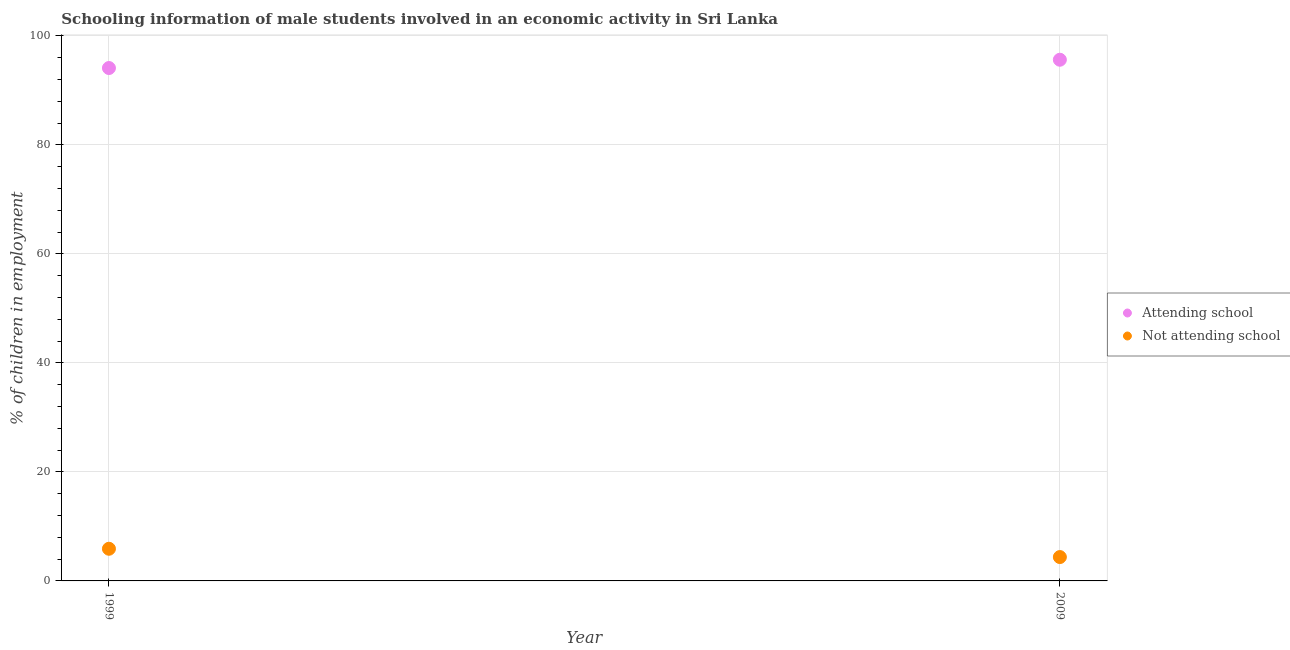Across all years, what is the maximum percentage of employed males who are attending school?
Offer a very short reply. 95.62. Across all years, what is the minimum percentage of employed males who are not attending school?
Keep it short and to the point. 4.38. In which year was the percentage of employed males who are attending school minimum?
Your answer should be very brief. 1999. What is the total percentage of employed males who are not attending school in the graph?
Provide a short and direct response. 10.28. What is the difference between the percentage of employed males who are attending school in 1999 and that in 2009?
Provide a succinct answer. -1.52. What is the difference between the percentage of employed males who are attending school in 1999 and the percentage of employed males who are not attending school in 2009?
Provide a short and direct response. 89.72. What is the average percentage of employed males who are not attending school per year?
Provide a succinct answer. 5.14. In the year 1999, what is the difference between the percentage of employed males who are attending school and percentage of employed males who are not attending school?
Ensure brevity in your answer.  88.2. In how many years, is the percentage of employed males who are not attending school greater than 8 %?
Give a very brief answer. 0. What is the ratio of the percentage of employed males who are not attending school in 1999 to that in 2009?
Your response must be concise. 1.35. In how many years, is the percentage of employed males who are attending school greater than the average percentage of employed males who are attending school taken over all years?
Your answer should be compact. 1. Is the percentage of employed males who are attending school strictly greater than the percentage of employed males who are not attending school over the years?
Offer a terse response. Yes. How many years are there in the graph?
Your answer should be very brief. 2. What is the difference between two consecutive major ticks on the Y-axis?
Offer a terse response. 20. Does the graph contain grids?
Your answer should be very brief. Yes. Where does the legend appear in the graph?
Offer a terse response. Center right. How many legend labels are there?
Offer a very short reply. 2. What is the title of the graph?
Give a very brief answer. Schooling information of male students involved in an economic activity in Sri Lanka. Does "Male entrants" appear as one of the legend labels in the graph?
Your response must be concise. No. What is the label or title of the Y-axis?
Provide a short and direct response. % of children in employment. What is the % of children in employment in Attending school in 1999?
Offer a very short reply. 94.1. What is the % of children in employment of Attending school in 2009?
Your answer should be compact. 95.62. What is the % of children in employment in Not attending school in 2009?
Ensure brevity in your answer.  4.38. Across all years, what is the maximum % of children in employment in Attending school?
Provide a short and direct response. 95.62. Across all years, what is the minimum % of children in employment of Attending school?
Keep it short and to the point. 94.1. Across all years, what is the minimum % of children in employment in Not attending school?
Provide a succinct answer. 4.38. What is the total % of children in employment in Attending school in the graph?
Your response must be concise. 189.72. What is the total % of children in employment in Not attending school in the graph?
Your answer should be very brief. 10.28. What is the difference between the % of children in employment of Attending school in 1999 and that in 2009?
Make the answer very short. -1.52. What is the difference between the % of children in employment in Not attending school in 1999 and that in 2009?
Your answer should be compact. 1.52. What is the difference between the % of children in employment in Attending school in 1999 and the % of children in employment in Not attending school in 2009?
Offer a terse response. 89.72. What is the average % of children in employment of Attending school per year?
Your answer should be compact. 94.86. What is the average % of children in employment of Not attending school per year?
Your answer should be compact. 5.14. In the year 1999, what is the difference between the % of children in employment of Attending school and % of children in employment of Not attending school?
Keep it short and to the point. 88.2. In the year 2009, what is the difference between the % of children in employment in Attending school and % of children in employment in Not attending school?
Keep it short and to the point. 91.24. What is the ratio of the % of children in employment in Attending school in 1999 to that in 2009?
Offer a terse response. 0.98. What is the ratio of the % of children in employment in Not attending school in 1999 to that in 2009?
Your response must be concise. 1.35. What is the difference between the highest and the second highest % of children in employment in Attending school?
Offer a terse response. 1.52. What is the difference between the highest and the second highest % of children in employment of Not attending school?
Give a very brief answer. 1.52. What is the difference between the highest and the lowest % of children in employment in Attending school?
Give a very brief answer. 1.52. What is the difference between the highest and the lowest % of children in employment in Not attending school?
Your answer should be very brief. 1.52. 